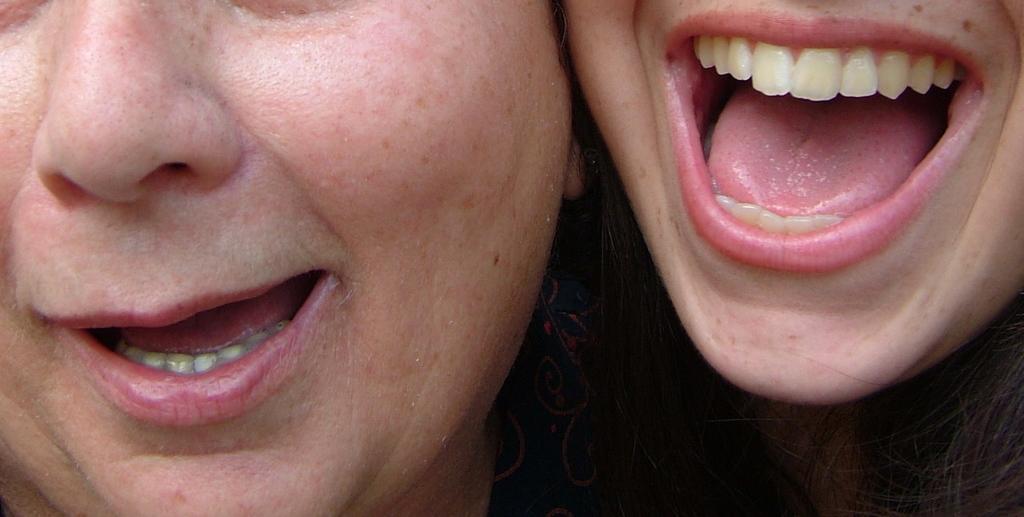Please provide a concise description of this image. In this picture there are two persons and it looks like one person is shouting and one person is smiling. 